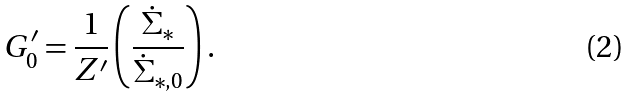<formula> <loc_0><loc_0><loc_500><loc_500>G _ { 0 } ^ { \prime } = \frac { 1 } { Z ^ { \prime } } \left ( \frac { \dot { \Sigma } _ { * } } { \dot { \Sigma } _ { * , 0 } } \right ) .</formula> 